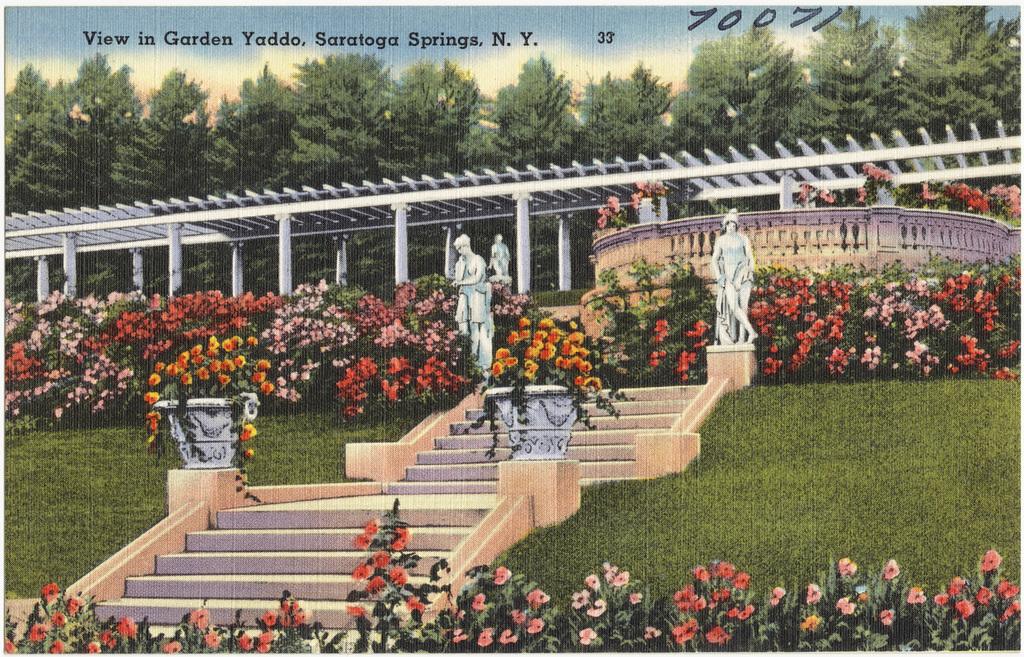Where is this taken?
Keep it short and to the point. Saratoga springs, ny. What numbers are mentioned on the right side?
Your answer should be very brief. 70071. 